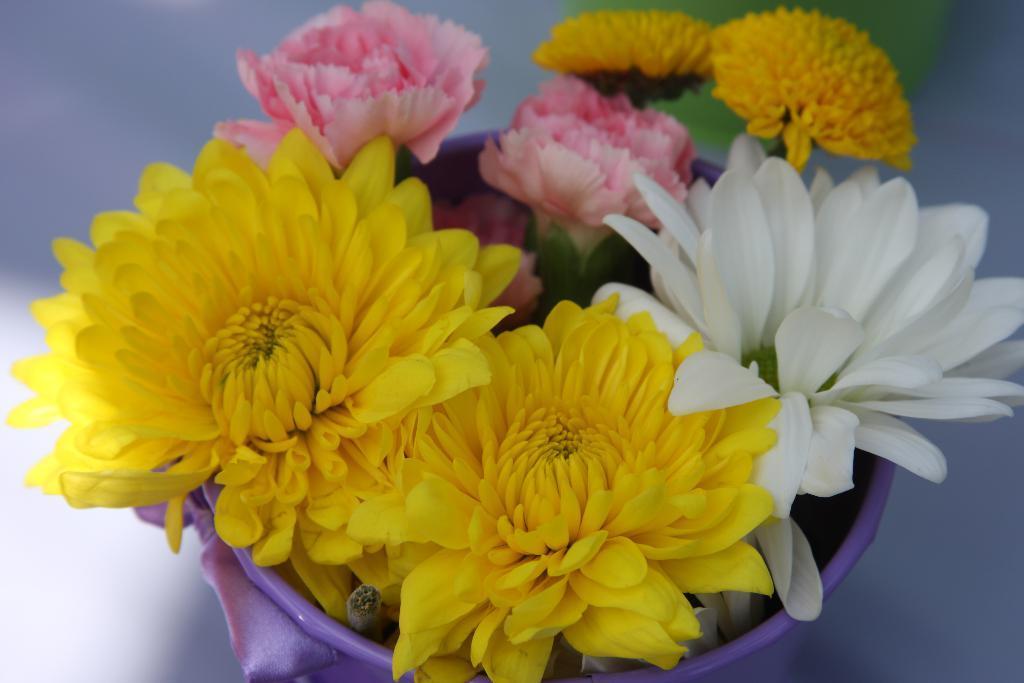Could you give a brief overview of what you see in this image? In this image in the center there are flowers inside the flower pot which is in the center and the background is blurry. 